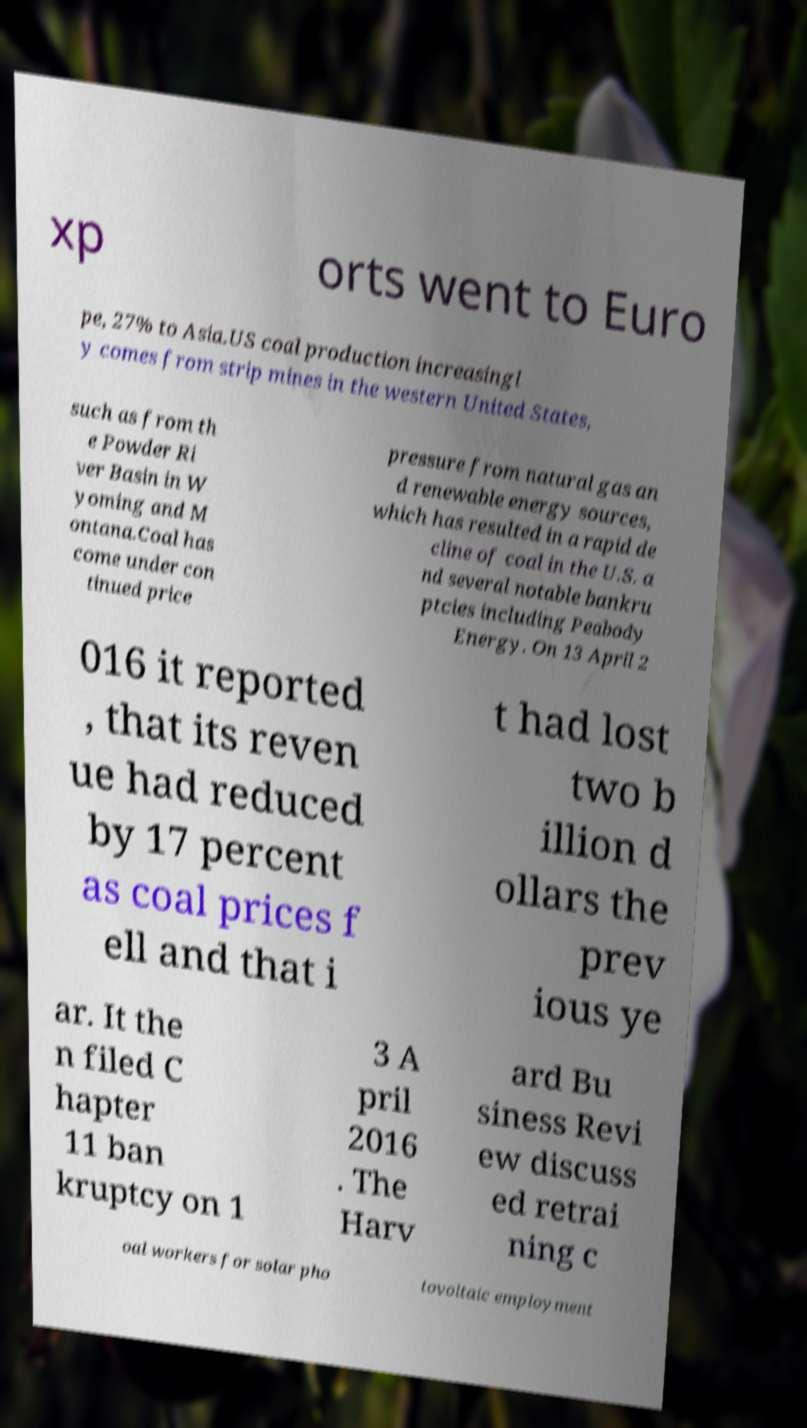What messages or text are displayed in this image? I need them in a readable, typed format. xp orts went to Euro pe, 27% to Asia.US coal production increasingl y comes from strip mines in the western United States, such as from th e Powder Ri ver Basin in W yoming and M ontana.Coal has come under con tinued price pressure from natural gas an d renewable energy sources, which has resulted in a rapid de cline of coal in the U.S. a nd several notable bankru ptcies including Peabody Energy. On 13 April 2 016 it reported , that its reven ue had reduced by 17 percent as coal prices f ell and that i t had lost two b illion d ollars the prev ious ye ar. It the n filed C hapter 11 ban kruptcy on 1 3 A pril 2016 . The Harv ard Bu siness Revi ew discuss ed retrai ning c oal workers for solar pho tovoltaic employment 